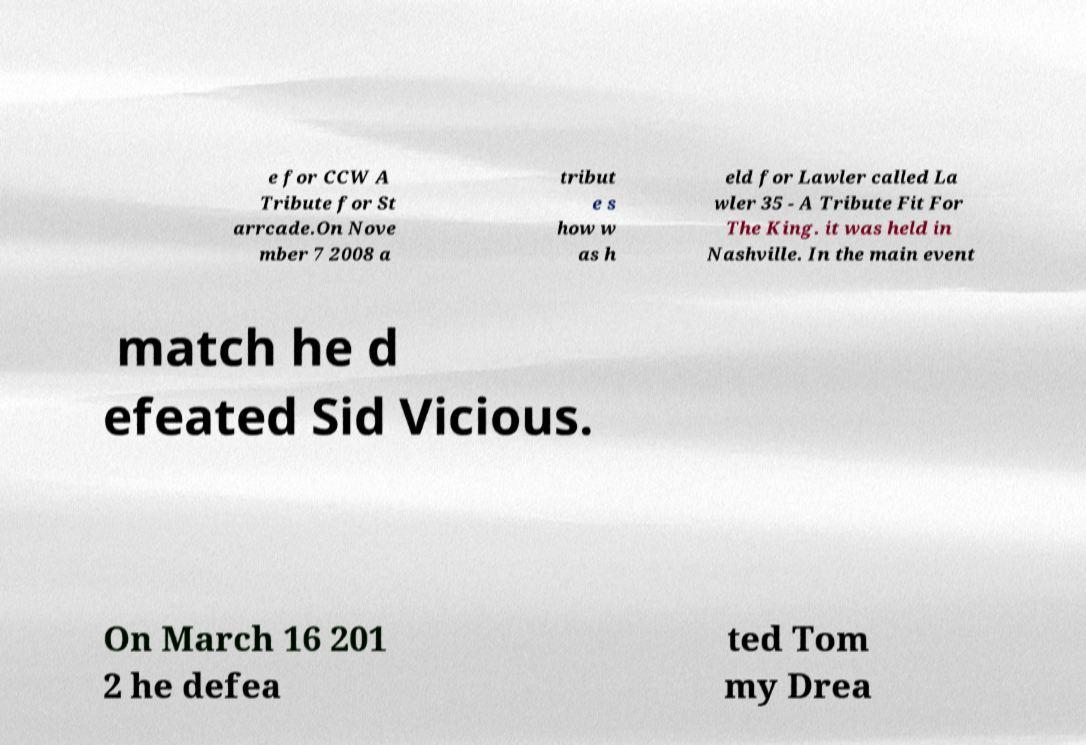For documentation purposes, I need the text within this image transcribed. Could you provide that? e for CCW A Tribute for St arrcade.On Nove mber 7 2008 a tribut e s how w as h eld for Lawler called La wler 35 - A Tribute Fit For The King. it was held in Nashville. In the main event match he d efeated Sid Vicious. On March 16 201 2 he defea ted Tom my Drea 